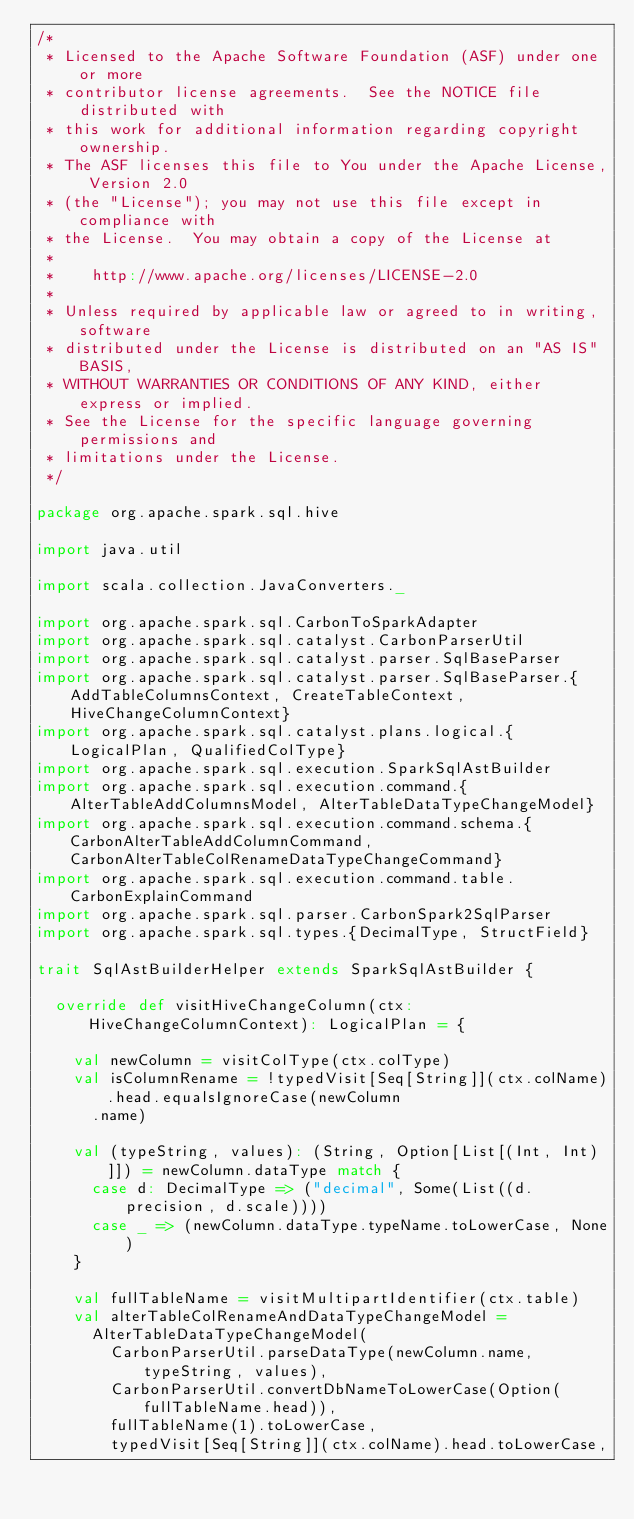Convert code to text. <code><loc_0><loc_0><loc_500><loc_500><_Scala_>/*
 * Licensed to the Apache Software Foundation (ASF) under one or more
 * contributor license agreements.  See the NOTICE file distributed with
 * this work for additional information regarding copyright ownership.
 * The ASF licenses this file to You under the Apache License, Version 2.0
 * (the "License"); you may not use this file except in compliance with
 * the License.  You may obtain a copy of the License at
 *
 *    http://www.apache.org/licenses/LICENSE-2.0
 *
 * Unless required by applicable law or agreed to in writing, software
 * distributed under the License is distributed on an "AS IS" BASIS,
 * WITHOUT WARRANTIES OR CONDITIONS OF ANY KIND, either express or implied.
 * See the License for the specific language governing permissions and
 * limitations under the License.
 */

package org.apache.spark.sql.hive

import java.util

import scala.collection.JavaConverters._

import org.apache.spark.sql.CarbonToSparkAdapter
import org.apache.spark.sql.catalyst.CarbonParserUtil
import org.apache.spark.sql.catalyst.parser.SqlBaseParser
import org.apache.spark.sql.catalyst.parser.SqlBaseParser.{AddTableColumnsContext, CreateTableContext, HiveChangeColumnContext}
import org.apache.spark.sql.catalyst.plans.logical.{LogicalPlan, QualifiedColType}
import org.apache.spark.sql.execution.SparkSqlAstBuilder
import org.apache.spark.sql.execution.command.{AlterTableAddColumnsModel, AlterTableDataTypeChangeModel}
import org.apache.spark.sql.execution.command.schema.{CarbonAlterTableAddColumnCommand, CarbonAlterTableColRenameDataTypeChangeCommand}
import org.apache.spark.sql.execution.command.table.CarbonExplainCommand
import org.apache.spark.sql.parser.CarbonSpark2SqlParser
import org.apache.spark.sql.types.{DecimalType, StructField}

trait SqlAstBuilderHelper extends SparkSqlAstBuilder {

  override def visitHiveChangeColumn(ctx: HiveChangeColumnContext): LogicalPlan = {

    val newColumn = visitColType(ctx.colType)
    val isColumnRename = !typedVisit[Seq[String]](ctx.colName).head.equalsIgnoreCase(newColumn
      .name)

    val (typeString, values): (String, Option[List[(Int, Int)]]) = newColumn.dataType match {
      case d: DecimalType => ("decimal", Some(List((d.precision, d.scale))))
      case _ => (newColumn.dataType.typeName.toLowerCase, None)
    }

    val fullTableName = visitMultipartIdentifier(ctx.table)
    val alterTableColRenameAndDataTypeChangeModel =
      AlterTableDataTypeChangeModel(
        CarbonParserUtil.parseDataType(newColumn.name, typeString, values),
        CarbonParserUtil.convertDbNameToLowerCase(Option(fullTableName.head)),
        fullTableName(1).toLowerCase,
        typedVisit[Seq[String]](ctx.colName).head.toLowerCase,</code> 